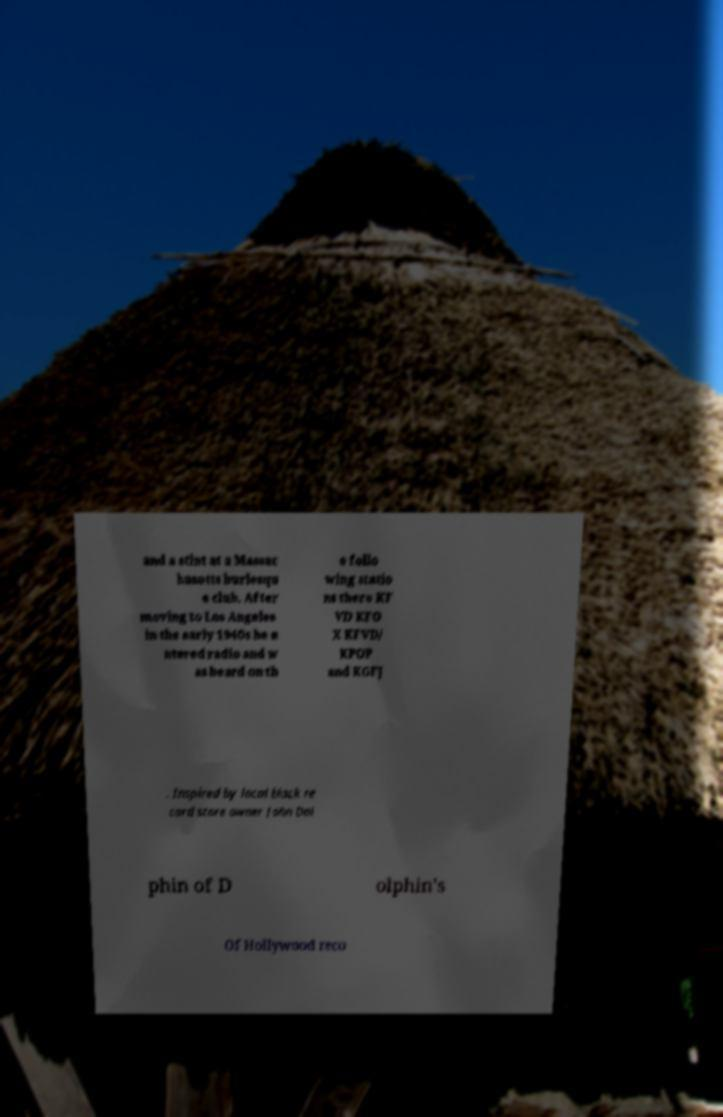For documentation purposes, I need the text within this image transcribed. Could you provide that? and a stint at a Massac husetts burlesqu e club. After moving to Los Angeles in the early 1940s he e ntered radio and w as heard on th e follo wing statio ns there KF VD KFO X KFVD/ KPOP and KGFJ . Inspired by local black re cord store owner John Dol phin of D olphin's Of Hollywood reco 